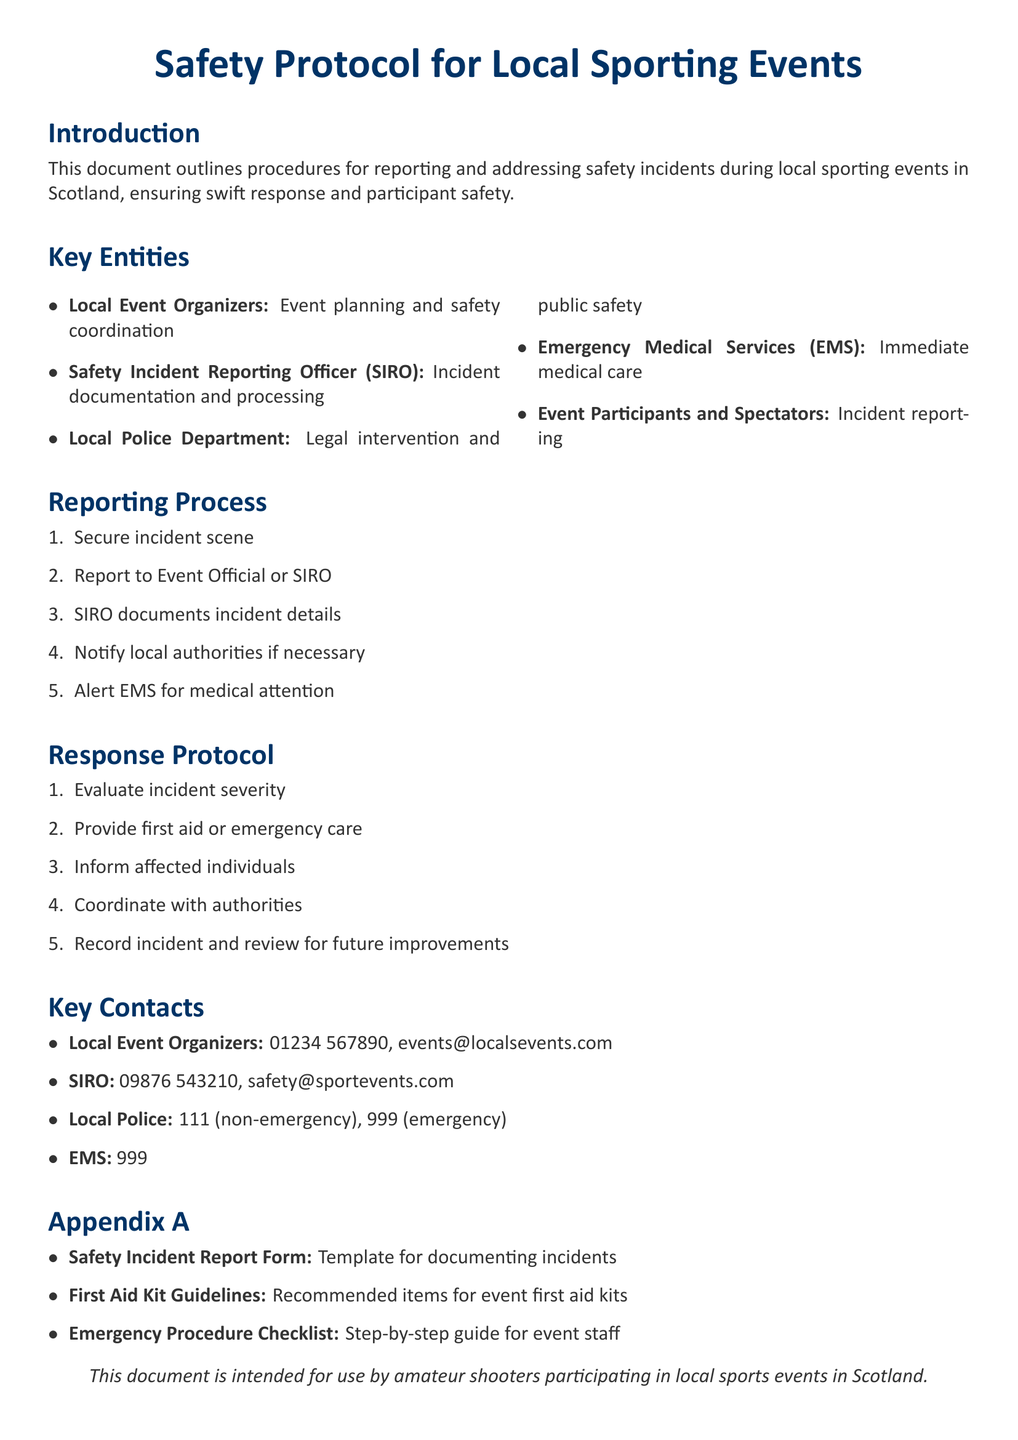What are the key entities involved in safety incidents? The key entities listed in the document include local event organizers, the Safety Incident Reporting Officer (SIRO), local police department, Emergency Medical Services (EMS), and event participants and spectators.
Answer: Local event organizers, SIRO, local police department, EMS, event participants and spectators What is the contact number for the SIRO? The document provides contact details including the SIRO's phone number, which is mentioned in the key contacts section.
Answer: 09876 543210 What is the first step in the reporting process? The reporting process outlines several steps, and the first step is specified in order.
Answer: Secure incident scene How many steps are in the response protocol? The response protocol consists of several outlined steps, and counting them gives the total.
Answer: Five What item is found in Appendix A? Appendix A lists various items that are relevant for the document's context, and one is specified among them.
Answer: Safety Incident Report Form What should be notified if medical attention is necessary? The document specifies which service should be alerted for medical care in the reporting process.
Answer: EMS What is the primary purpose of this document? The introductory section of the document states its intended use and purpose clearly.
Answer: Reporting and addressing safety incidents What is the color used for headings? The document mentions the color codes used for different sections, including the headings.
Answer: RGB(0,51,102) How is the incident severity evaluated? The document describes the procedures for response protocol, including evaluation steps that are part of the incident management process.
Answer: Evaluate incident severity 